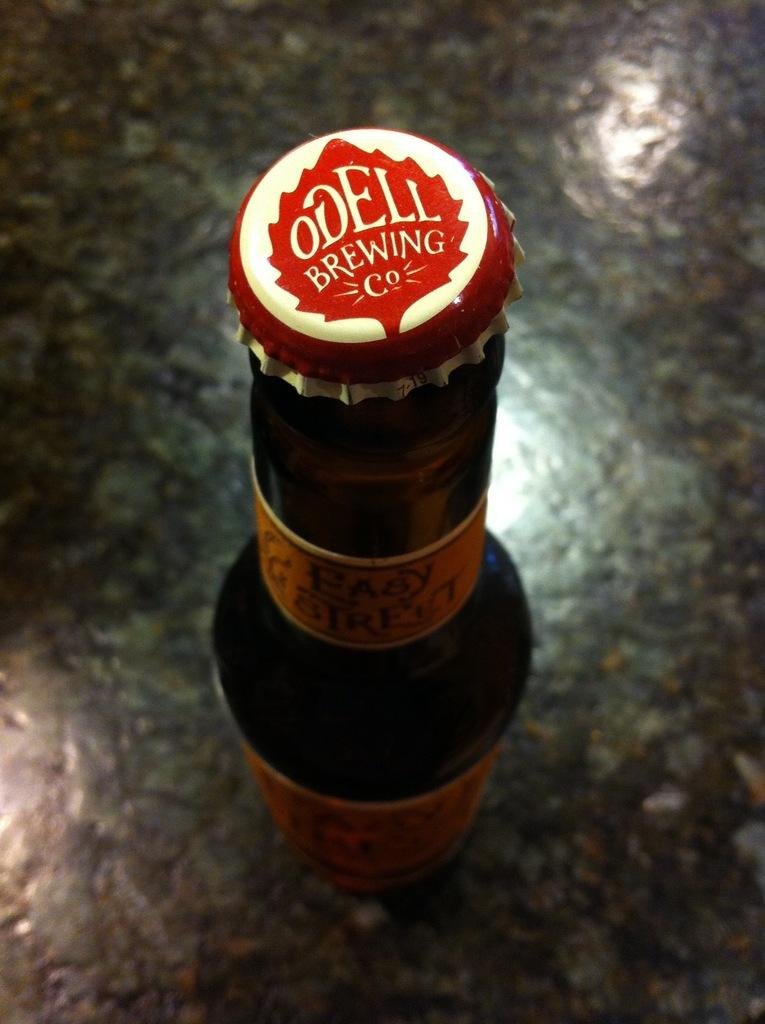<image>
Present a compact description of the photo's key features. Bottle of beer with a red cap that says "Odell Brewing Co". 